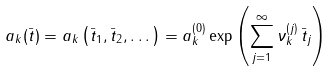Convert formula to latex. <formula><loc_0><loc_0><loc_500><loc_500>a _ { k } ( \bar { t } ) = a _ { k } \left ( \bar { t } _ { 1 } , \bar { t } _ { 2 } , \dots \right ) = a _ { k } ^ { ( 0 ) } \exp \left ( \sum _ { j = 1 } ^ { \infty } \nu _ { k } ^ { ( j ) } \, \bar { t } _ { j } \right )</formula> 